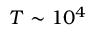Convert formula to latex. <formula><loc_0><loc_0><loc_500><loc_500>T \sim 1 0 ^ { 4 }</formula> 